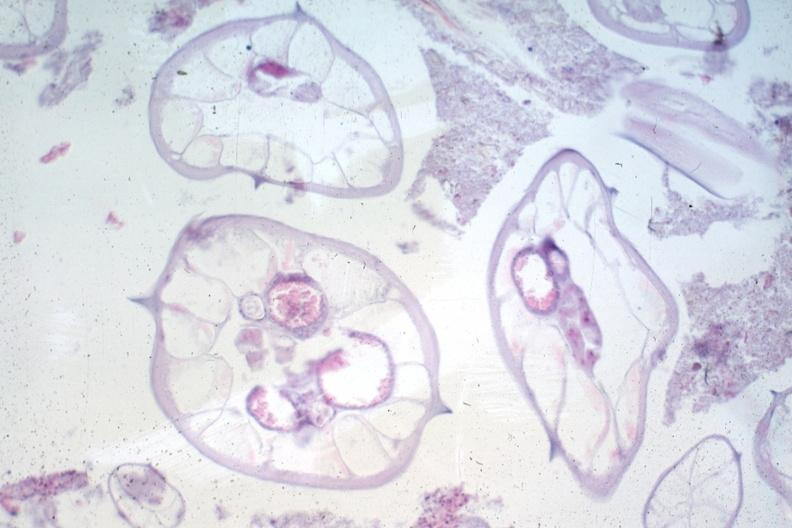what is present?
Answer the question using a single word or phrase. Pinworm 